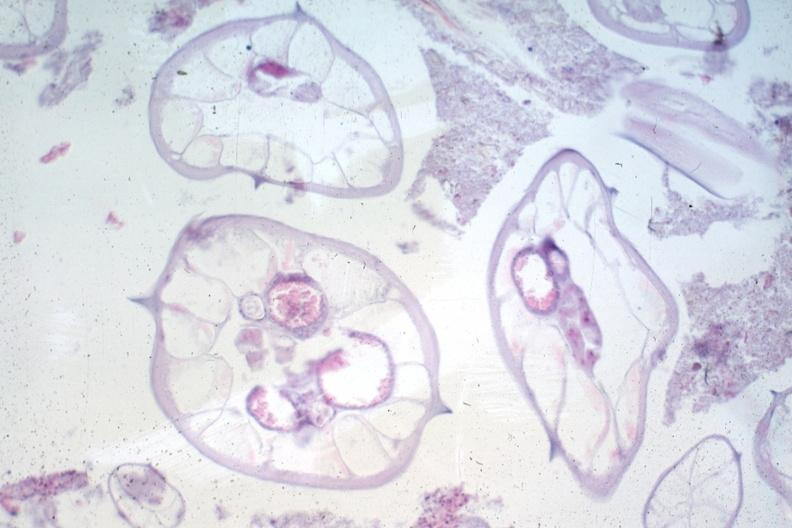what is present?
Answer the question using a single word or phrase. Pinworm 